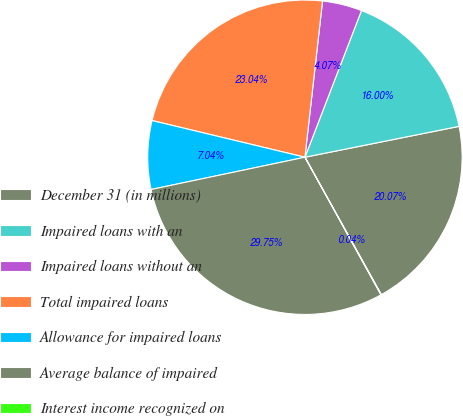Convert chart. <chart><loc_0><loc_0><loc_500><loc_500><pie_chart><fcel>December 31 (in millions)<fcel>Impaired loans with an<fcel>Impaired loans without an<fcel>Total impaired loans<fcel>Allowance for impaired loans<fcel>Average balance of impaired<fcel>Interest income recognized on<nl><fcel>20.07%<fcel>16.0%<fcel>4.07%<fcel>23.04%<fcel>7.04%<fcel>29.75%<fcel>0.04%<nl></chart> 